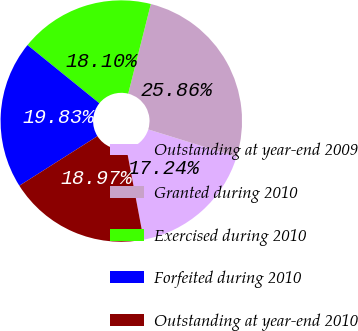Convert chart. <chart><loc_0><loc_0><loc_500><loc_500><pie_chart><fcel>Outstanding at year-end 2009<fcel>Granted during 2010<fcel>Exercised during 2010<fcel>Forfeited during 2010<fcel>Outstanding at year-end 2010<nl><fcel>17.24%<fcel>25.86%<fcel>18.1%<fcel>19.83%<fcel>18.97%<nl></chart> 